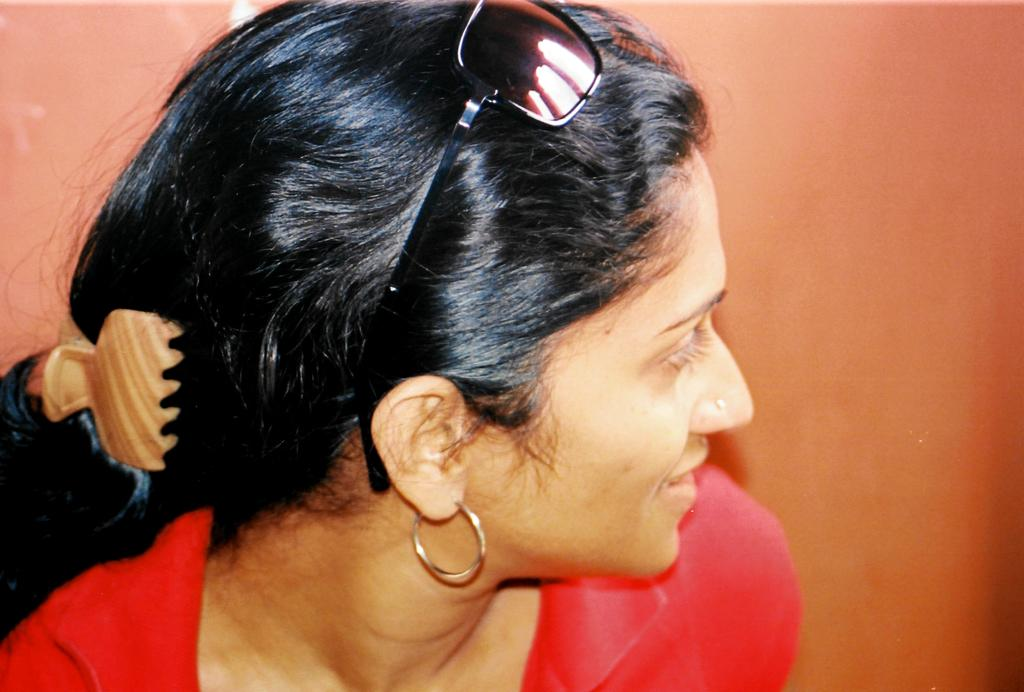Who is the main subject in the image? There is a woman in the image. What is the woman wearing? The woman is wearing red clothes. What accessories can be seen on the woman? The woman is wearing earrings, goggles, and a hair clip. What is visible in the background of the image? There is a wall in the background of the image. What type of needle is the woman using to produce a garment in the image? There is no needle or garment production visible in the image. 